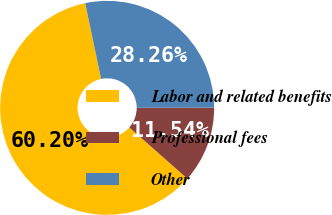Convert chart to OTSL. <chart><loc_0><loc_0><loc_500><loc_500><pie_chart><fcel>Labor and related benefits<fcel>Professional fees<fcel>Other<nl><fcel>60.2%<fcel>11.54%<fcel>28.26%<nl></chart> 